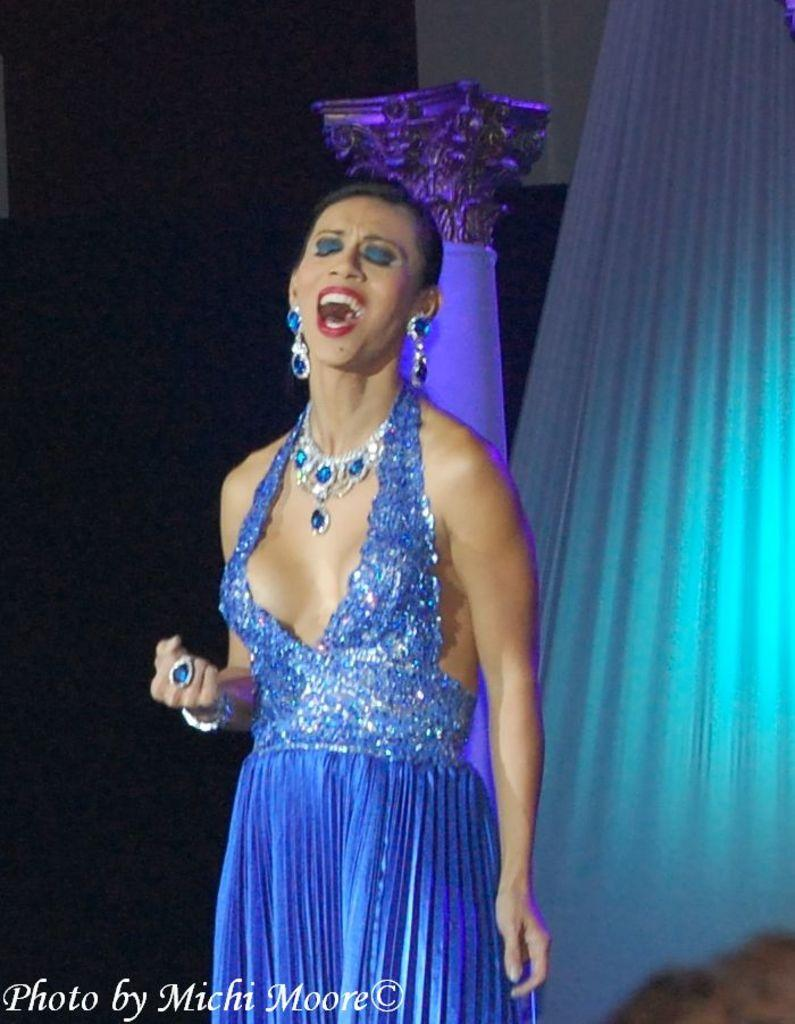What is the main subject of the image? There is a woman standing in the image. What can be seen in the background of the image? The background of the image is dark. Are there any architectural features in the image? Yes, there is a pillar and a wall in the image. What is the purpose of the curtain in the image? The curtain may be used for privacy or to control light. Where is the text located in the image? The text is in the bottom left side of the image. Can you tell me how deep the quicksand is in the image? There is no quicksand present in the image; it features a woman standing with a curtain, pillar, and wall in the background. How many breaths does the woman take in the image? It is not possible to determine the number of breaths the woman takes in the image, as it is a still photograph. 